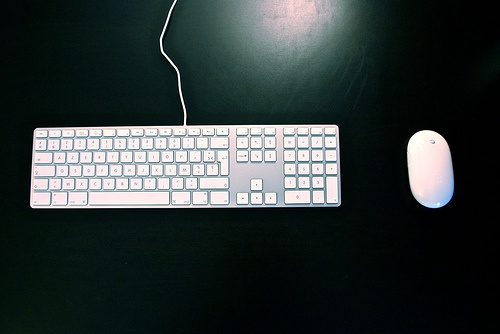Describe the objects in this image and their specific colors. I can see keyboard in black, white, darkgray, and gray tones and mouse in black, lightgray, and lightblue tones in this image. 